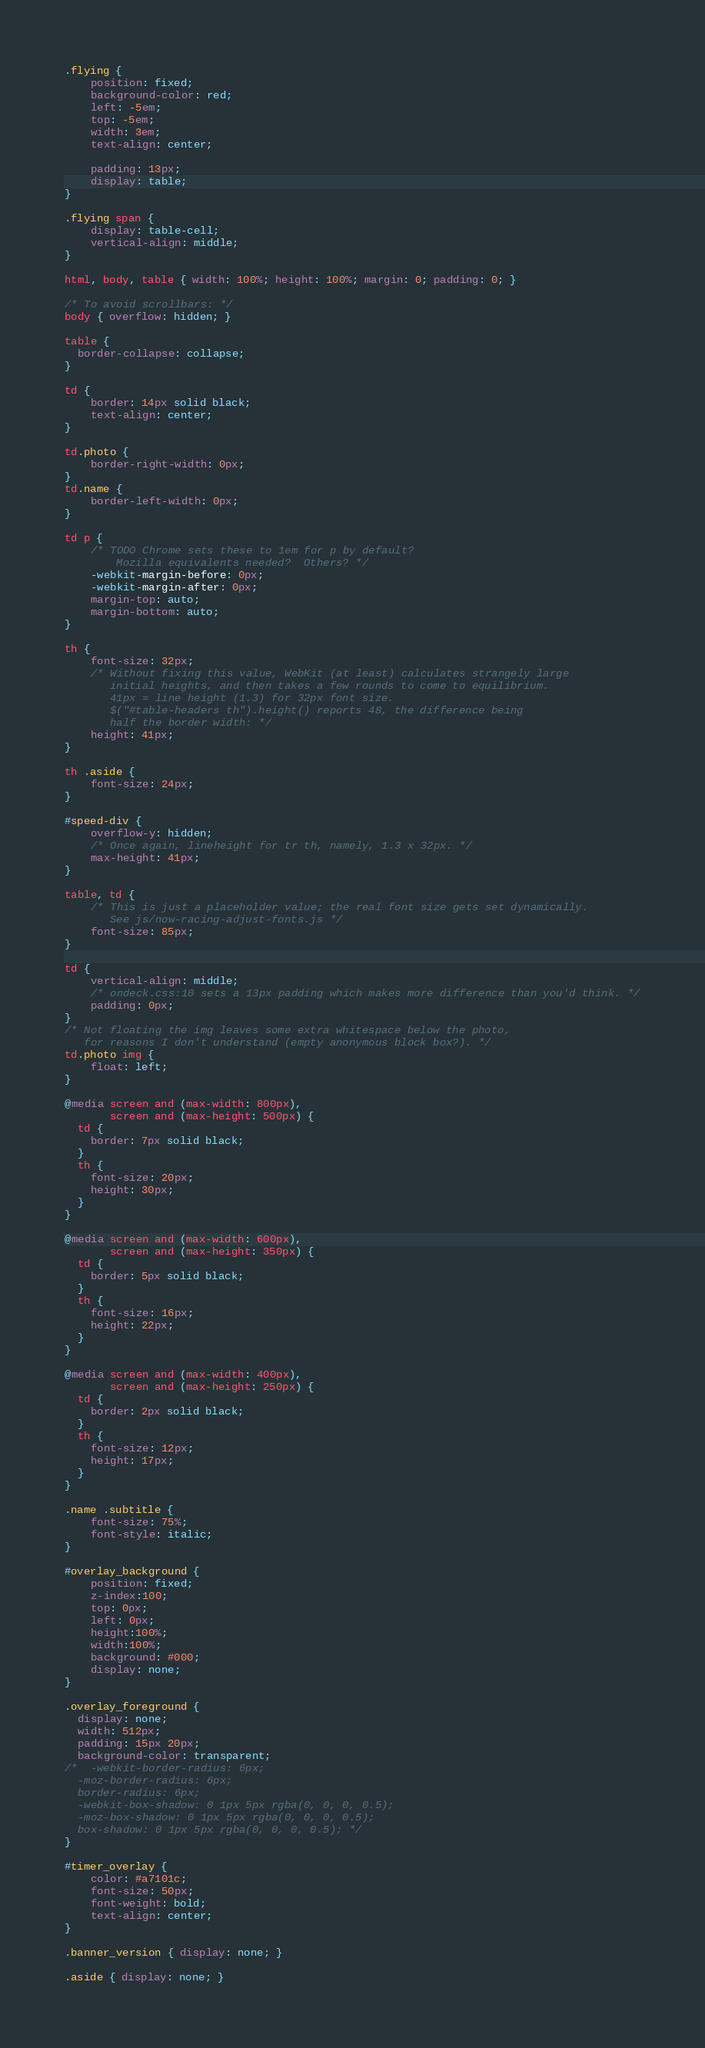<code> <loc_0><loc_0><loc_500><loc_500><_CSS_>
.flying {
    position: fixed;
    background-color: red;
    left: -5em;
    top: -5em;
    width: 3em;
    text-align: center;

    padding: 13px;
    display: table;
}

.flying span {
    display: table-cell;
    vertical-align: middle;
}

html, body, table { width: 100%; height: 100%; margin: 0; padding: 0; }

/* To avoid scrollbars: */
body { overflow: hidden; }

table { 
  border-collapse: collapse;
}

td {
    border: 14px solid black;
    text-align: center;
}

td.photo {
    border-right-width: 0px;
}
td.name {
    border-left-width: 0px;
}

td p {
    /* TODO Chrome sets these to 1em for p by default?
        Mozilla equivalents needed?  Others? */
    -webkit-margin-before: 0px;
    -webkit-margin-after: 0px;
    margin-top: auto;
    margin-bottom: auto;
}

th {
    font-size: 32px;
    /* Without fixing this value, WebKit (at least) calculates strangely large
       initial heights, and then takes a few rounds to come to equilibrium.
       41px = line height (1.3) for 32px font size.
       $("#table-headers th").height() reports 48, the difference being
       half the border width: */
    height: 41px;
}

th .aside {
    font-size: 24px;
}

#speed-div {
    overflow-y: hidden;
    /* Once again, lineheight for tr th, namely, 1.3 x 32px. */
    max-height: 41px;
}

table, td {
    /* This is just a placeholder value; the real font size gets set dynamically.
       See js/now-racing-adjust-fonts.js */
    font-size: 85px;
}

td {
    vertical-align: middle;
    /* ondeck.css:10 sets a 13px padding which makes more difference than you'd think. */
    padding: 0px;
}
/* Not floating the img leaves some extra whitespace below the photo,
   for reasons I don't understand (empty anonymous block box?). */
td.photo img {
    float: left;
}

@media screen and (max-width: 800px),
       screen and (max-height: 500px) {
  td {
    border: 7px solid black;
  }
  th {
    font-size: 20px;
    height: 30px;
  }
}

@media screen and (max-width: 600px),
       screen and (max-height: 350px) {
  td {
    border: 5px solid black;
  }
  th {
    font-size: 16px;
    height: 22px;
  }
}

@media screen and (max-width: 400px), 
       screen and (max-height: 250px) {
  td {
    border: 2px solid black;
  }
  th {
    font-size: 12px;
    height: 17px;
  }
}

.name .subtitle {
    font-size: 75%;
    font-style: italic;
}

#overlay_background {
    position: fixed;
    z-index:100;
    top: 0px;
    left: 0px;
    height:100%;
    width:100%;
    background: #000;
    display: none;
}

.overlay_foreground {
  display: none;
  width: 512px;
  padding: 15px 20px;
  background-color: transparent;
/*  -webkit-border-radius: 6px;
  -moz-border-radius: 6px;
  border-radius: 6px;
  -webkit-box-shadow: 0 1px 5px rgba(0, 0, 0, 0.5);
  -moz-box-shadow: 0 1px 5px rgba(0, 0, 0, 0.5);
  box-shadow: 0 1px 5px rgba(0, 0, 0, 0.5); */
}

#timer_overlay {
    color: #a7101c;
    font-size: 50px;
    font-weight: bold;
    text-align: center;
}

.banner_version { display: none; }

.aside { display: none; }
</code> 